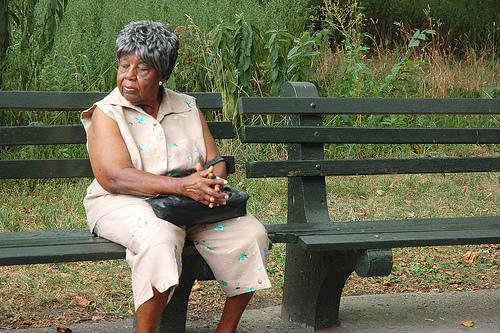Provide a short description of the elderly woman's appearance. The elderly woman has short grey hair, wearing a tan and blue flower patterned dress, and a round earring on her ear. Mention what the elderly woman is doing while sitting on the park bench. The elderly woman is enjoying nature, clutching a black purse on her lap, and has her hands folded. Count the number of park benches in the image and describe their conditions. There are two wooden park benches: one with an elderly woman sitting and the other one is an empty green bench. Give a brief sentiment analysis of the image. The image evokes a sense of peacefulness and serenity as the elderly woman enjoys nature while sitting on a park bench. Describe the pattern and colors of the elderly woman's clothes. The elderly woman is wearing a tan and blue flower patterned dress, which has blue flowers on her shirt and pants. List the objects found next to the park benches. Stray dead leaf, tall green plants, tall dry brown grass, weeds behind the benches, and a paved sidewalk. Discuss the type of bag the elderly woman has and its position. The elderly woman has a black leather purse placed in her lap while she sits on the park bench. What is the condition of the wooden park bench that the woman is not sitting on? The wooden park bench not occupied by the woman is empty, green, and made of wood slats without any notable damage. Briefly describe the condition of the grass around the bench area. There are tall wild green grass, tall brown grass in distance, brown leaves on the ground, and brown dead weeds. Explain the positions of the elderly woman's hands. The elderly woman has her hands clasped together and resting on her black purse in her lap. 